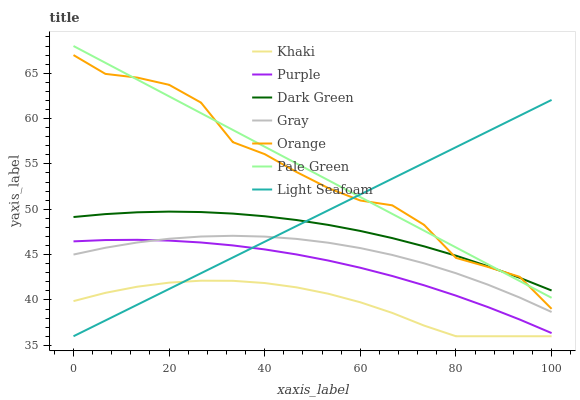Does Khaki have the minimum area under the curve?
Answer yes or no. Yes. Does Purple have the minimum area under the curve?
Answer yes or no. No. Does Purple have the maximum area under the curve?
Answer yes or no. No. Is Khaki the smoothest?
Answer yes or no. No. Is Khaki the roughest?
Answer yes or no. No. Does Purple have the lowest value?
Answer yes or no. No. Does Purple have the highest value?
Answer yes or no. No. Is Khaki less than Dark Green?
Answer yes or no. Yes. Is Pale Green greater than Purple?
Answer yes or no. Yes. Does Khaki intersect Dark Green?
Answer yes or no. No. 